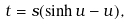Convert formula to latex. <formula><loc_0><loc_0><loc_500><loc_500>t = s ( \sinh u - u ) ,</formula> 